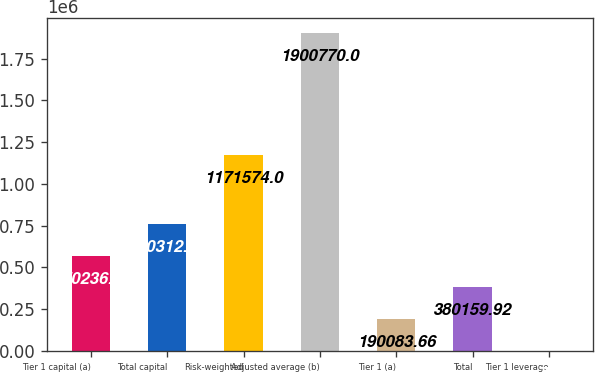Convert chart. <chart><loc_0><loc_0><loc_500><loc_500><bar_chart><fcel>Tier 1 capital (a)<fcel>Total capital<fcel>Risk-weighted<fcel>Adjusted average (b)<fcel>Tier 1 (a)<fcel>Total<fcel>Tier 1 leverage<nl><fcel>570236<fcel>760312<fcel>1.17157e+06<fcel>1.90077e+06<fcel>190084<fcel>380160<fcel>7.4<nl></chart> 